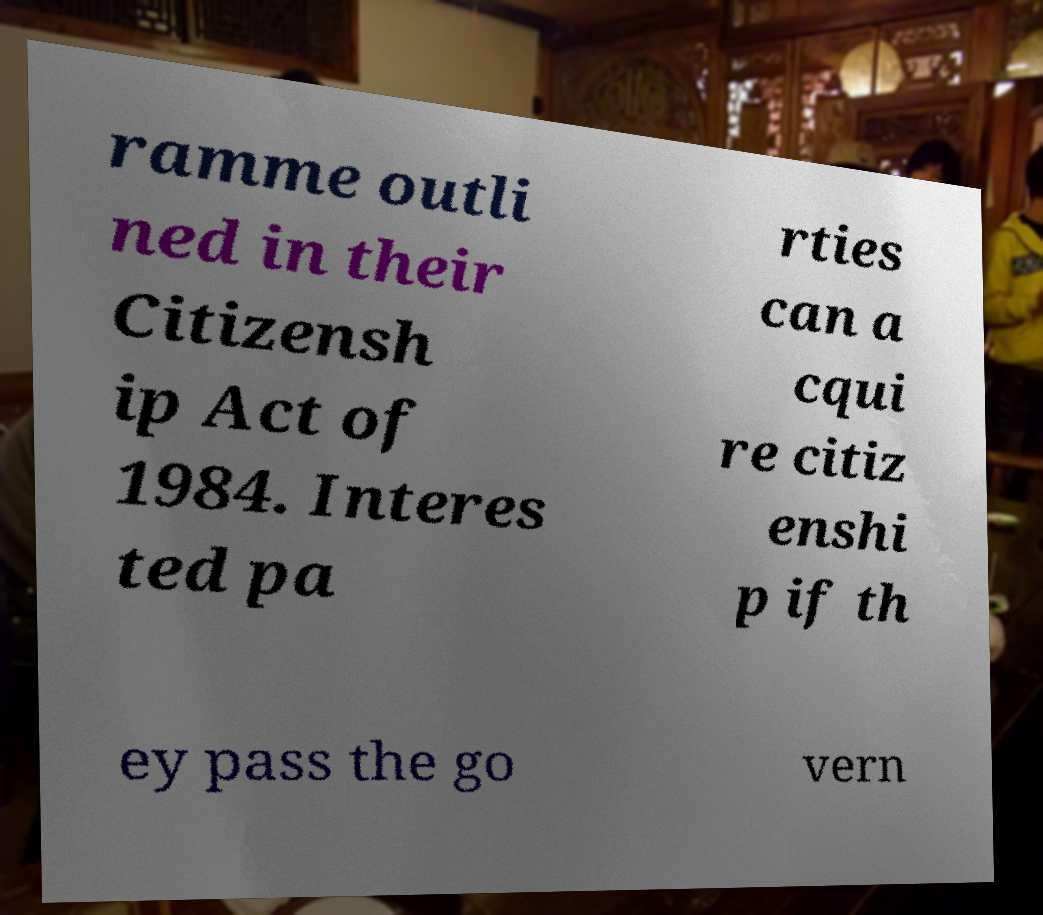Could you assist in decoding the text presented in this image and type it out clearly? ramme outli ned in their Citizensh ip Act of 1984. Interes ted pa rties can a cqui re citiz enshi p if th ey pass the go vern 